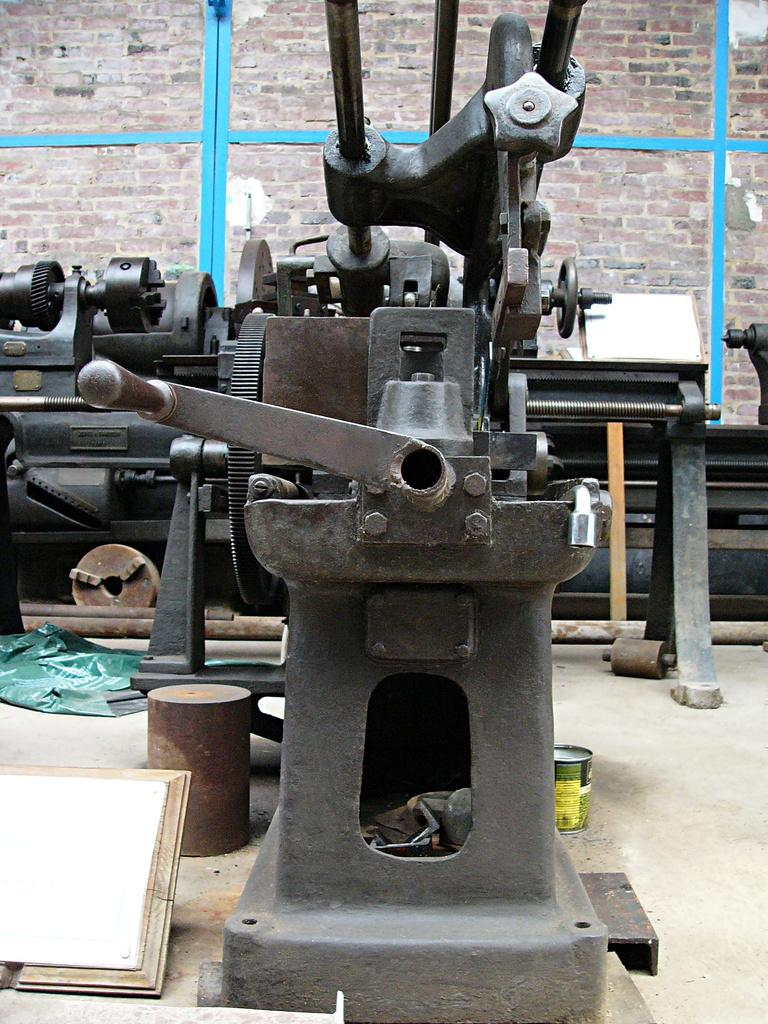What type of items are visible on the floor in the image? There are iron items in the image. Can you describe the location of these items? The iron items are kept on the floor. What is visible in the background of the image? There is a wall visible in the background of the image. What type of stocking can be seen on the iron items in the image? There are no stockings present on the iron items in the image. What type of grain is visible in the image? There is no grain visible in the image. 